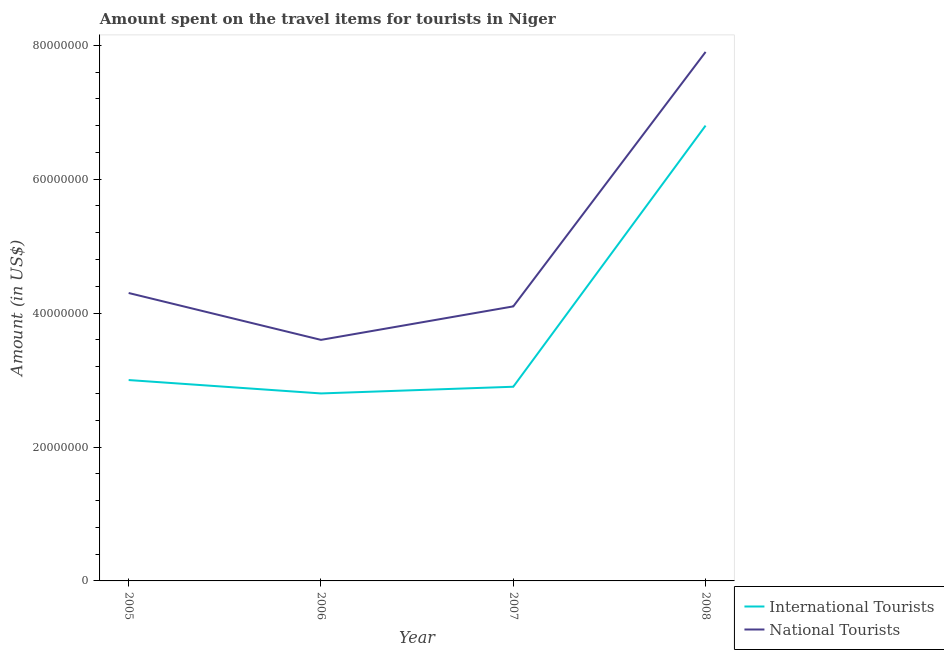How many different coloured lines are there?
Offer a very short reply. 2. What is the amount spent on travel items of national tourists in 2007?
Offer a very short reply. 4.10e+07. Across all years, what is the maximum amount spent on travel items of international tourists?
Your answer should be compact. 6.80e+07. Across all years, what is the minimum amount spent on travel items of national tourists?
Make the answer very short. 3.60e+07. What is the total amount spent on travel items of international tourists in the graph?
Offer a very short reply. 1.55e+08. What is the difference between the amount spent on travel items of international tourists in 2005 and that in 2008?
Provide a succinct answer. -3.80e+07. What is the difference between the amount spent on travel items of national tourists in 2007 and the amount spent on travel items of international tourists in 2006?
Your answer should be compact. 1.30e+07. What is the average amount spent on travel items of national tourists per year?
Offer a very short reply. 4.98e+07. In the year 2008, what is the difference between the amount spent on travel items of international tourists and amount spent on travel items of national tourists?
Keep it short and to the point. -1.10e+07. In how many years, is the amount spent on travel items of international tourists greater than 40000000 US$?
Your answer should be compact. 1. What is the ratio of the amount spent on travel items of international tourists in 2006 to that in 2007?
Offer a very short reply. 0.97. What is the difference between the highest and the second highest amount spent on travel items of national tourists?
Offer a terse response. 3.60e+07. What is the difference between the highest and the lowest amount spent on travel items of international tourists?
Provide a short and direct response. 4.00e+07. Does the amount spent on travel items of international tourists monotonically increase over the years?
Make the answer very short. No. Is the amount spent on travel items of national tourists strictly greater than the amount spent on travel items of international tourists over the years?
Offer a very short reply. Yes. Is the amount spent on travel items of international tourists strictly less than the amount spent on travel items of national tourists over the years?
Make the answer very short. Yes. How many lines are there?
Offer a terse response. 2. Are the values on the major ticks of Y-axis written in scientific E-notation?
Your answer should be compact. No. Where does the legend appear in the graph?
Offer a terse response. Bottom right. What is the title of the graph?
Provide a short and direct response. Amount spent on the travel items for tourists in Niger. Does "IMF concessional" appear as one of the legend labels in the graph?
Provide a succinct answer. No. What is the Amount (in US$) in International Tourists in 2005?
Make the answer very short. 3.00e+07. What is the Amount (in US$) in National Tourists in 2005?
Provide a short and direct response. 4.30e+07. What is the Amount (in US$) in International Tourists in 2006?
Your response must be concise. 2.80e+07. What is the Amount (in US$) of National Tourists in 2006?
Your answer should be compact. 3.60e+07. What is the Amount (in US$) in International Tourists in 2007?
Offer a very short reply. 2.90e+07. What is the Amount (in US$) in National Tourists in 2007?
Provide a succinct answer. 4.10e+07. What is the Amount (in US$) of International Tourists in 2008?
Your response must be concise. 6.80e+07. What is the Amount (in US$) in National Tourists in 2008?
Your answer should be very brief. 7.90e+07. Across all years, what is the maximum Amount (in US$) of International Tourists?
Make the answer very short. 6.80e+07. Across all years, what is the maximum Amount (in US$) in National Tourists?
Your answer should be compact. 7.90e+07. Across all years, what is the minimum Amount (in US$) in International Tourists?
Your answer should be very brief. 2.80e+07. Across all years, what is the minimum Amount (in US$) of National Tourists?
Make the answer very short. 3.60e+07. What is the total Amount (in US$) in International Tourists in the graph?
Your answer should be compact. 1.55e+08. What is the total Amount (in US$) in National Tourists in the graph?
Keep it short and to the point. 1.99e+08. What is the difference between the Amount (in US$) of National Tourists in 2005 and that in 2007?
Keep it short and to the point. 2.00e+06. What is the difference between the Amount (in US$) in International Tourists in 2005 and that in 2008?
Provide a short and direct response. -3.80e+07. What is the difference between the Amount (in US$) in National Tourists in 2005 and that in 2008?
Your answer should be very brief. -3.60e+07. What is the difference between the Amount (in US$) in National Tourists in 2006 and that in 2007?
Your answer should be very brief. -5.00e+06. What is the difference between the Amount (in US$) in International Tourists in 2006 and that in 2008?
Provide a succinct answer. -4.00e+07. What is the difference between the Amount (in US$) in National Tourists in 2006 and that in 2008?
Make the answer very short. -4.30e+07. What is the difference between the Amount (in US$) in International Tourists in 2007 and that in 2008?
Your answer should be very brief. -3.90e+07. What is the difference between the Amount (in US$) in National Tourists in 2007 and that in 2008?
Offer a terse response. -3.80e+07. What is the difference between the Amount (in US$) of International Tourists in 2005 and the Amount (in US$) of National Tourists in 2006?
Your answer should be compact. -6.00e+06. What is the difference between the Amount (in US$) in International Tourists in 2005 and the Amount (in US$) in National Tourists in 2007?
Your answer should be compact. -1.10e+07. What is the difference between the Amount (in US$) in International Tourists in 2005 and the Amount (in US$) in National Tourists in 2008?
Give a very brief answer. -4.90e+07. What is the difference between the Amount (in US$) of International Tourists in 2006 and the Amount (in US$) of National Tourists in 2007?
Keep it short and to the point. -1.30e+07. What is the difference between the Amount (in US$) in International Tourists in 2006 and the Amount (in US$) in National Tourists in 2008?
Provide a short and direct response. -5.10e+07. What is the difference between the Amount (in US$) in International Tourists in 2007 and the Amount (in US$) in National Tourists in 2008?
Provide a short and direct response. -5.00e+07. What is the average Amount (in US$) in International Tourists per year?
Your response must be concise. 3.88e+07. What is the average Amount (in US$) of National Tourists per year?
Make the answer very short. 4.98e+07. In the year 2005, what is the difference between the Amount (in US$) of International Tourists and Amount (in US$) of National Tourists?
Offer a very short reply. -1.30e+07. In the year 2006, what is the difference between the Amount (in US$) of International Tourists and Amount (in US$) of National Tourists?
Your answer should be compact. -8.00e+06. In the year 2007, what is the difference between the Amount (in US$) of International Tourists and Amount (in US$) of National Tourists?
Your response must be concise. -1.20e+07. In the year 2008, what is the difference between the Amount (in US$) of International Tourists and Amount (in US$) of National Tourists?
Provide a short and direct response. -1.10e+07. What is the ratio of the Amount (in US$) of International Tourists in 2005 to that in 2006?
Provide a succinct answer. 1.07. What is the ratio of the Amount (in US$) in National Tourists in 2005 to that in 2006?
Keep it short and to the point. 1.19. What is the ratio of the Amount (in US$) in International Tourists in 2005 to that in 2007?
Your response must be concise. 1.03. What is the ratio of the Amount (in US$) of National Tourists in 2005 to that in 2007?
Provide a short and direct response. 1.05. What is the ratio of the Amount (in US$) in International Tourists in 2005 to that in 2008?
Offer a very short reply. 0.44. What is the ratio of the Amount (in US$) of National Tourists in 2005 to that in 2008?
Your answer should be very brief. 0.54. What is the ratio of the Amount (in US$) in International Tourists in 2006 to that in 2007?
Your response must be concise. 0.97. What is the ratio of the Amount (in US$) of National Tourists in 2006 to that in 2007?
Give a very brief answer. 0.88. What is the ratio of the Amount (in US$) in International Tourists in 2006 to that in 2008?
Your response must be concise. 0.41. What is the ratio of the Amount (in US$) of National Tourists in 2006 to that in 2008?
Keep it short and to the point. 0.46. What is the ratio of the Amount (in US$) in International Tourists in 2007 to that in 2008?
Provide a succinct answer. 0.43. What is the ratio of the Amount (in US$) of National Tourists in 2007 to that in 2008?
Provide a short and direct response. 0.52. What is the difference between the highest and the second highest Amount (in US$) in International Tourists?
Your answer should be compact. 3.80e+07. What is the difference between the highest and the second highest Amount (in US$) in National Tourists?
Give a very brief answer. 3.60e+07. What is the difference between the highest and the lowest Amount (in US$) in International Tourists?
Ensure brevity in your answer.  4.00e+07. What is the difference between the highest and the lowest Amount (in US$) in National Tourists?
Give a very brief answer. 4.30e+07. 